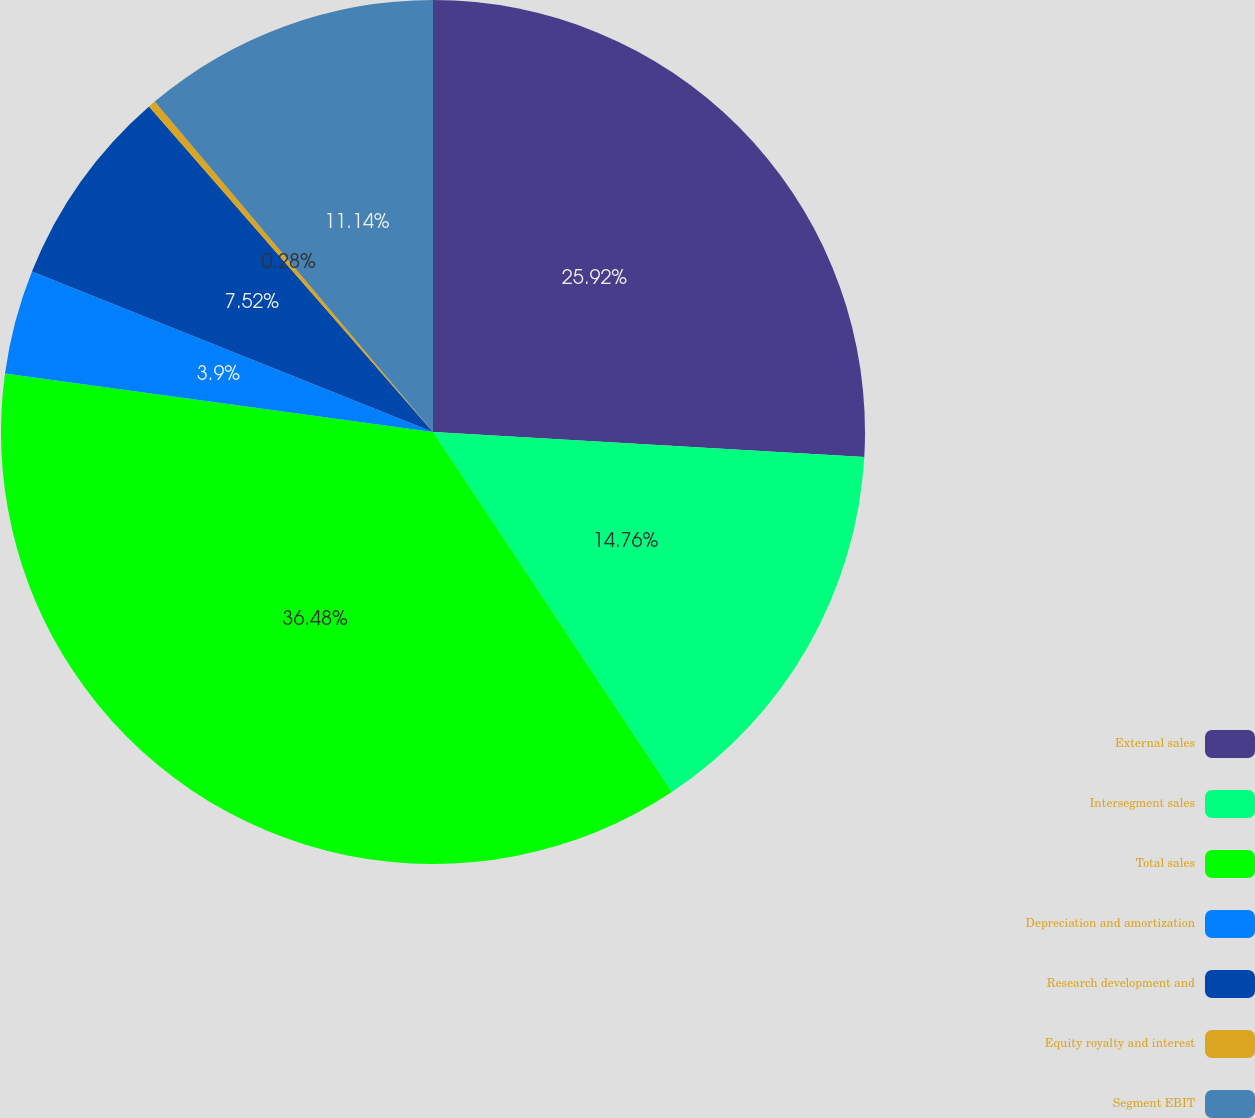Convert chart to OTSL. <chart><loc_0><loc_0><loc_500><loc_500><pie_chart><fcel>External sales<fcel>Intersegment sales<fcel>Total sales<fcel>Depreciation and amortization<fcel>Research development and<fcel>Equity royalty and interest<fcel>Segment EBIT<nl><fcel>25.92%<fcel>14.76%<fcel>36.49%<fcel>3.9%<fcel>7.52%<fcel>0.28%<fcel>11.14%<nl></chart> 